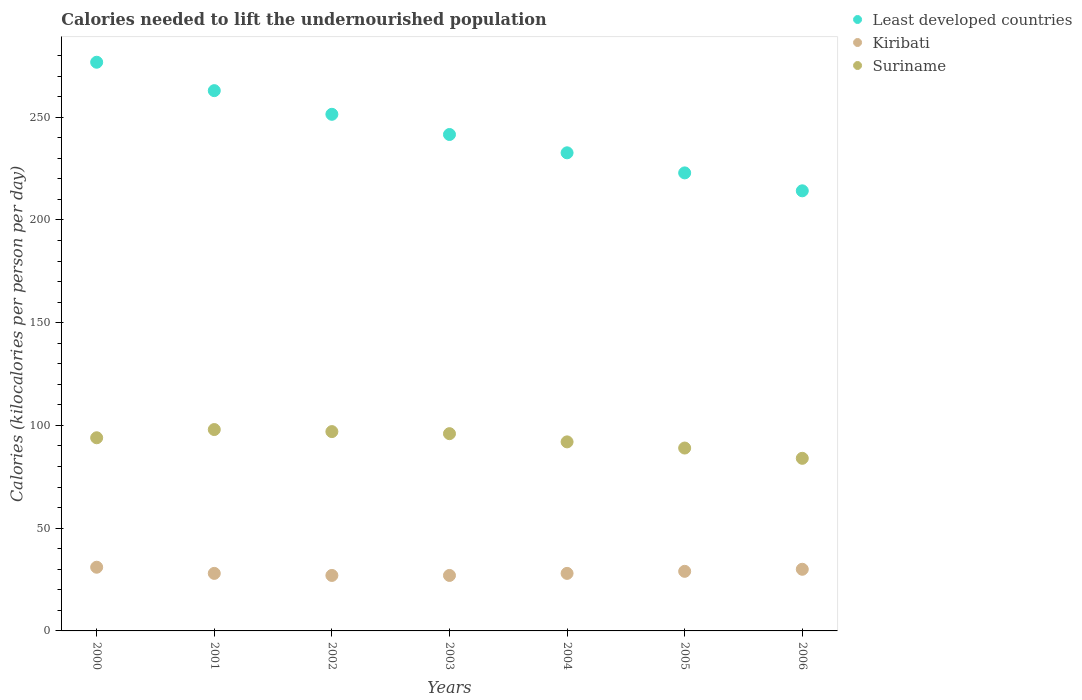Is the number of dotlines equal to the number of legend labels?
Provide a short and direct response. Yes. What is the total calories needed to lift the undernourished population in Kiribati in 2002?
Provide a succinct answer. 27. Across all years, what is the maximum total calories needed to lift the undernourished population in Kiribati?
Make the answer very short. 31. Across all years, what is the minimum total calories needed to lift the undernourished population in Suriname?
Your answer should be very brief. 84. In which year was the total calories needed to lift the undernourished population in Suriname maximum?
Provide a succinct answer. 2001. What is the total total calories needed to lift the undernourished population in Kiribati in the graph?
Your response must be concise. 200. What is the difference between the total calories needed to lift the undernourished population in Suriname in 2004 and that in 2005?
Provide a short and direct response. 3. What is the difference between the total calories needed to lift the undernourished population in Least developed countries in 2001 and the total calories needed to lift the undernourished population in Suriname in 2000?
Give a very brief answer. 168.93. What is the average total calories needed to lift the undernourished population in Kiribati per year?
Offer a terse response. 28.57. In the year 2005, what is the difference between the total calories needed to lift the undernourished population in Suriname and total calories needed to lift the undernourished population in Least developed countries?
Keep it short and to the point. -133.9. What is the ratio of the total calories needed to lift the undernourished population in Least developed countries in 2005 to that in 2006?
Provide a short and direct response. 1.04. Is the total calories needed to lift the undernourished population in Suriname in 2000 less than that in 2005?
Provide a succinct answer. No. What is the difference between the highest and the lowest total calories needed to lift the undernourished population in Kiribati?
Your answer should be compact. 4. Is the sum of the total calories needed to lift the undernourished population in Kiribati in 2000 and 2001 greater than the maximum total calories needed to lift the undernourished population in Least developed countries across all years?
Your response must be concise. No. Is the total calories needed to lift the undernourished population in Kiribati strictly greater than the total calories needed to lift the undernourished population in Suriname over the years?
Provide a short and direct response. No. Is the total calories needed to lift the undernourished population in Suriname strictly less than the total calories needed to lift the undernourished population in Least developed countries over the years?
Ensure brevity in your answer.  Yes. How many dotlines are there?
Your response must be concise. 3. How are the legend labels stacked?
Keep it short and to the point. Vertical. What is the title of the graph?
Your answer should be compact. Calories needed to lift the undernourished population. Does "New Zealand" appear as one of the legend labels in the graph?
Provide a short and direct response. No. What is the label or title of the Y-axis?
Give a very brief answer. Calories (kilocalories per person per day). What is the Calories (kilocalories per person per day) of Least developed countries in 2000?
Keep it short and to the point. 276.76. What is the Calories (kilocalories per person per day) of Kiribati in 2000?
Your answer should be compact. 31. What is the Calories (kilocalories per person per day) in Suriname in 2000?
Your response must be concise. 94. What is the Calories (kilocalories per person per day) in Least developed countries in 2001?
Offer a very short reply. 262.93. What is the Calories (kilocalories per person per day) of Kiribati in 2001?
Make the answer very short. 28. What is the Calories (kilocalories per person per day) in Least developed countries in 2002?
Your answer should be very brief. 251.42. What is the Calories (kilocalories per person per day) of Kiribati in 2002?
Offer a very short reply. 27. What is the Calories (kilocalories per person per day) in Suriname in 2002?
Offer a very short reply. 97. What is the Calories (kilocalories per person per day) in Least developed countries in 2003?
Keep it short and to the point. 241.59. What is the Calories (kilocalories per person per day) of Kiribati in 2003?
Provide a short and direct response. 27. What is the Calories (kilocalories per person per day) in Suriname in 2003?
Provide a succinct answer. 96. What is the Calories (kilocalories per person per day) of Least developed countries in 2004?
Ensure brevity in your answer.  232.67. What is the Calories (kilocalories per person per day) in Kiribati in 2004?
Provide a short and direct response. 28. What is the Calories (kilocalories per person per day) of Suriname in 2004?
Offer a very short reply. 92. What is the Calories (kilocalories per person per day) in Least developed countries in 2005?
Provide a succinct answer. 222.9. What is the Calories (kilocalories per person per day) in Suriname in 2005?
Your answer should be very brief. 89. What is the Calories (kilocalories per person per day) in Least developed countries in 2006?
Your response must be concise. 214.18. What is the Calories (kilocalories per person per day) in Kiribati in 2006?
Provide a succinct answer. 30. Across all years, what is the maximum Calories (kilocalories per person per day) in Least developed countries?
Provide a short and direct response. 276.76. Across all years, what is the maximum Calories (kilocalories per person per day) in Kiribati?
Give a very brief answer. 31. Across all years, what is the maximum Calories (kilocalories per person per day) in Suriname?
Provide a succinct answer. 98. Across all years, what is the minimum Calories (kilocalories per person per day) in Least developed countries?
Your response must be concise. 214.18. Across all years, what is the minimum Calories (kilocalories per person per day) in Kiribati?
Your answer should be very brief. 27. What is the total Calories (kilocalories per person per day) in Least developed countries in the graph?
Make the answer very short. 1702.46. What is the total Calories (kilocalories per person per day) in Kiribati in the graph?
Your answer should be compact. 200. What is the total Calories (kilocalories per person per day) of Suriname in the graph?
Make the answer very short. 650. What is the difference between the Calories (kilocalories per person per day) in Least developed countries in 2000 and that in 2001?
Keep it short and to the point. 13.82. What is the difference between the Calories (kilocalories per person per day) of Kiribati in 2000 and that in 2001?
Provide a short and direct response. 3. What is the difference between the Calories (kilocalories per person per day) of Suriname in 2000 and that in 2001?
Provide a short and direct response. -4. What is the difference between the Calories (kilocalories per person per day) in Least developed countries in 2000 and that in 2002?
Your response must be concise. 25.34. What is the difference between the Calories (kilocalories per person per day) of Kiribati in 2000 and that in 2002?
Your answer should be very brief. 4. What is the difference between the Calories (kilocalories per person per day) in Suriname in 2000 and that in 2002?
Give a very brief answer. -3. What is the difference between the Calories (kilocalories per person per day) of Least developed countries in 2000 and that in 2003?
Ensure brevity in your answer.  35.17. What is the difference between the Calories (kilocalories per person per day) of Suriname in 2000 and that in 2003?
Your response must be concise. -2. What is the difference between the Calories (kilocalories per person per day) of Least developed countries in 2000 and that in 2004?
Give a very brief answer. 44.08. What is the difference between the Calories (kilocalories per person per day) in Suriname in 2000 and that in 2004?
Provide a short and direct response. 2. What is the difference between the Calories (kilocalories per person per day) in Least developed countries in 2000 and that in 2005?
Offer a terse response. 53.85. What is the difference between the Calories (kilocalories per person per day) of Least developed countries in 2000 and that in 2006?
Offer a very short reply. 62.58. What is the difference between the Calories (kilocalories per person per day) of Least developed countries in 2001 and that in 2002?
Your answer should be very brief. 11.51. What is the difference between the Calories (kilocalories per person per day) in Kiribati in 2001 and that in 2002?
Your answer should be very brief. 1. What is the difference between the Calories (kilocalories per person per day) of Suriname in 2001 and that in 2002?
Your answer should be very brief. 1. What is the difference between the Calories (kilocalories per person per day) of Least developed countries in 2001 and that in 2003?
Provide a short and direct response. 21.34. What is the difference between the Calories (kilocalories per person per day) in Least developed countries in 2001 and that in 2004?
Keep it short and to the point. 30.26. What is the difference between the Calories (kilocalories per person per day) of Kiribati in 2001 and that in 2004?
Make the answer very short. 0. What is the difference between the Calories (kilocalories per person per day) of Least developed countries in 2001 and that in 2005?
Your answer should be very brief. 40.03. What is the difference between the Calories (kilocalories per person per day) in Least developed countries in 2001 and that in 2006?
Provide a succinct answer. 48.75. What is the difference between the Calories (kilocalories per person per day) in Least developed countries in 2002 and that in 2003?
Offer a very short reply. 9.83. What is the difference between the Calories (kilocalories per person per day) of Suriname in 2002 and that in 2003?
Give a very brief answer. 1. What is the difference between the Calories (kilocalories per person per day) in Least developed countries in 2002 and that in 2004?
Make the answer very short. 18.74. What is the difference between the Calories (kilocalories per person per day) of Kiribati in 2002 and that in 2004?
Your answer should be very brief. -1. What is the difference between the Calories (kilocalories per person per day) of Least developed countries in 2002 and that in 2005?
Offer a terse response. 28.51. What is the difference between the Calories (kilocalories per person per day) of Suriname in 2002 and that in 2005?
Provide a succinct answer. 8. What is the difference between the Calories (kilocalories per person per day) in Least developed countries in 2002 and that in 2006?
Offer a very short reply. 37.24. What is the difference between the Calories (kilocalories per person per day) in Least developed countries in 2003 and that in 2004?
Offer a terse response. 8.92. What is the difference between the Calories (kilocalories per person per day) in Least developed countries in 2003 and that in 2005?
Your answer should be compact. 18.69. What is the difference between the Calories (kilocalories per person per day) in Least developed countries in 2003 and that in 2006?
Provide a succinct answer. 27.41. What is the difference between the Calories (kilocalories per person per day) of Kiribati in 2003 and that in 2006?
Your answer should be compact. -3. What is the difference between the Calories (kilocalories per person per day) of Suriname in 2003 and that in 2006?
Make the answer very short. 12. What is the difference between the Calories (kilocalories per person per day) in Least developed countries in 2004 and that in 2005?
Your response must be concise. 9.77. What is the difference between the Calories (kilocalories per person per day) of Suriname in 2004 and that in 2005?
Offer a terse response. 3. What is the difference between the Calories (kilocalories per person per day) of Least developed countries in 2004 and that in 2006?
Offer a terse response. 18.49. What is the difference between the Calories (kilocalories per person per day) of Kiribati in 2004 and that in 2006?
Provide a succinct answer. -2. What is the difference between the Calories (kilocalories per person per day) of Suriname in 2004 and that in 2006?
Offer a very short reply. 8. What is the difference between the Calories (kilocalories per person per day) in Least developed countries in 2005 and that in 2006?
Offer a very short reply. 8.72. What is the difference between the Calories (kilocalories per person per day) of Least developed countries in 2000 and the Calories (kilocalories per person per day) of Kiribati in 2001?
Your answer should be very brief. 248.76. What is the difference between the Calories (kilocalories per person per day) of Least developed countries in 2000 and the Calories (kilocalories per person per day) of Suriname in 2001?
Provide a succinct answer. 178.76. What is the difference between the Calories (kilocalories per person per day) of Kiribati in 2000 and the Calories (kilocalories per person per day) of Suriname in 2001?
Give a very brief answer. -67. What is the difference between the Calories (kilocalories per person per day) in Least developed countries in 2000 and the Calories (kilocalories per person per day) in Kiribati in 2002?
Keep it short and to the point. 249.76. What is the difference between the Calories (kilocalories per person per day) in Least developed countries in 2000 and the Calories (kilocalories per person per day) in Suriname in 2002?
Your response must be concise. 179.76. What is the difference between the Calories (kilocalories per person per day) of Kiribati in 2000 and the Calories (kilocalories per person per day) of Suriname in 2002?
Ensure brevity in your answer.  -66. What is the difference between the Calories (kilocalories per person per day) in Least developed countries in 2000 and the Calories (kilocalories per person per day) in Kiribati in 2003?
Offer a very short reply. 249.76. What is the difference between the Calories (kilocalories per person per day) of Least developed countries in 2000 and the Calories (kilocalories per person per day) of Suriname in 2003?
Your answer should be very brief. 180.76. What is the difference between the Calories (kilocalories per person per day) in Kiribati in 2000 and the Calories (kilocalories per person per day) in Suriname in 2003?
Your answer should be compact. -65. What is the difference between the Calories (kilocalories per person per day) of Least developed countries in 2000 and the Calories (kilocalories per person per day) of Kiribati in 2004?
Ensure brevity in your answer.  248.76. What is the difference between the Calories (kilocalories per person per day) in Least developed countries in 2000 and the Calories (kilocalories per person per day) in Suriname in 2004?
Give a very brief answer. 184.76. What is the difference between the Calories (kilocalories per person per day) of Kiribati in 2000 and the Calories (kilocalories per person per day) of Suriname in 2004?
Ensure brevity in your answer.  -61. What is the difference between the Calories (kilocalories per person per day) in Least developed countries in 2000 and the Calories (kilocalories per person per day) in Kiribati in 2005?
Your answer should be compact. 247.76. What is the difference between the Calories (kilocalories per person per day) in Least developed countries in 2000 and the Calories (kilocalories per person per day) in Suriname in 2005?
Provide a succinct answer. 187.76. What is the difference between the Calories (kilocalories per person per day) of Kiribati in 2000 and the Calories (kilocalories per person per day) of Suriname in 2005?
Your answer should be compact. -58. What is the difference between the Calories (kilocalories per person per day) of Least developed countries in 2000 and the Calories (kilocalories per person per day) of Kiribati in 2006?
Give a very brief answer. 246.76. What is the difference between the Calories (kilocalories per person per day) of Least developed countries in 2000 and the Calories (kilocalories per person per day) of Suriname in 2006?
Ensure brevity in your answer.  192.76. What is the difference between the Calories (kilocalories per person per day) in Kiribati in 2000 and the Calories (kilocalories per person per day) in Suriname in 2006?
Provide a short and direct response. -53. What is the difference between the Calories (kilocalories per person per day) in Least developed countries in 2001 and the Calories (kilocalories per person per day) in Kiribati in 2002?
Offer a terse response. 235.93. What is the difference between the Calories (kilocalories per person per day) of Least developed countries in 2001 and the Calories (kilocalories per person per day) of Suriname in 2002?
Your answer should be very brief. 165.93. What is the difference between the Calories (kilocalories per person per day) in Kiribati in 2001 and the Calories (kilocalories per person per day) in Suriname in 2002?
Offer a terse response. -69. What is the difference between the Calories (kilocalories per person per day) in Least developed countries in 2001 and the Calories (kilocalories per person per day) in Kiribati in 2003?
Provide a short and direct response. 235.93. What is the difference between the Calories (kilocalories per person per day) in Least developed countries in 2001 and the Calories (kilocalories per person per day) in Suriname in 2003?
Make the answer very short. 166.93. What is the difference between the Calories (kilocalories per person per day) in Kiribati in 2001 and the Calories (kilocalories per person per day) in Suriname in 2003?
Give a very brief answer. -68. What is the difference between the Calories (kilocalories per person per day) in Least developed countries in 2001 and the Calories (kilocalories per person per day) in Kiribati in 2004?
Offer a terse response. 234.93. What is the difference between the Calories (kilocalories per person per day) in Least developed countries in 2001 and the Calories (kilocalories per person per day) in Suriname in 2004?
Provide a succinct answer. 170.93. What is the difference between the Calories (kilocalories per person per day) in Kiribati in 2001 and the Calories (kilocalories per person per day) in Suriname in 2004?
Ensure brevity in your answer.  -64. What is the difference between the Calories (kilocalories per person per day) in Least developed countries in 2001 and the Calories (kilocalories per person per day) in Kiribati in 2005?
Make the answer very short. 233.93. What is the difference between the Calories (kilocalories per person per day) in Least developed countries in 2001 and the Calories (kilocalories per person per day) in Suriname in 2005?
Keep it short and to the point. 173.93. What is the difference between the Calories (kilocalories per person per day) of Kiribati in 2001 and the Calories (kilocalories per person per day) of Suriname in 2005?
Provide a short and direct response. -61. What is the difference between the Calories (kilocalories per person per day) of Least developed countries in 2001 and the Calories (kilocalories per person per day) of Kiribati in 2006?
Provide a short and direct response. 232.93. What is the difference between the Calories (kilocalories per person per day) of Least developed countries in 2001 and the Calories (kilocalories per person per day) of Suriname in 2006?
Keep it short and to the point. 178.93. What is the difference between the Calories (kilocalories per person per day) in Kiribati in 2001 and the Calories (kilocalories per person per day) in Suriname in 2006?
Provide a short and direct response. -56. What is the difference between the Calories (kilocalories per person per day) in Least developed countries in 2002 and the Calories (kilocalories per person per day) in Kiribati in 2003?
Offer a terse response. 224.42. What is the difference between the Calories (kilocalories per person per day) in Least developed countries in 2002 and the Calories (kilocalories per person per day) in Suriname in 2003?
Offer a terse response. 155.42. What is the difference between the Calories (kilocalories per person per day) of Kiribati in 2002 and the Calories (kilocalories per person per day) of Suriname in 2003?
Provide a short and direct response. -69. What is the difference between the Calories (kilocalories per person per day) in Least developed countries in 2002 and the Calories (kilocalories per person per day) in Kiribati in 2004?
Your answer should be compact. 223.42. What is the difference between the Calories (kilocalories per person per day) in Least developed countries in 2002 and the Calories (kilocalories per person per day) in Suriname in 2004?
Your answer should be very brief. 159.42. What is the difference between the Calories (kilocalories per person per day) of Kiribati in 2002 and the Calories (kilocalories per person per day) of Suriname in 2004?
Your answer should be compact. -65. What is the difference between the Calories (kilocalories per person per day) of Least developed countries in 2002 and the Calories (kilocalories per person per day) of Kiribati in 2005?
Your answer should be very brief. 222.42. What is the difference between the Calories (kilocalories per person per day) of Least developed countries in 2002 and the Calories (kilocalories per person per day) of Suriname in 2005?
Give a very brief answer. 162.42. What is the difference between the Calories (kilocalories per person per day) in Kiribati in 2002 and the Calories (kilocalories per person per day) in Suriname in 2005?
Provide a succinct answer. -62. What is the difference between the Calories (kilocalories per person per day) of Least developed countries in 2002 and the Calories (kilocalories per person per day) of Kiribati in 2006?
Give a very brief answer. 221.42. What is the difference between the Calories (kilocalories per person per day) of Least developed countries in 2002 and the Calories (kilocalories per person per day) of Suriname in 2006?
Give a very brief answer. 167.42. What is the difference between the Calories (kilocalories per person per day) of Kiribati in 2002 and the Calories (kilocalories per person per day) of Suriname in 2006?
Make the answer very short. -57. What is the difference between the Calories (kilocalories per person per day) of Least developed countries in 2003 and the Calories (kilocalories per person per day) of Kiribati in 2004?
Keep it short and to the point. 213.59. What is the difference between the Calories (kilocalories per person per day) in Least developed countries in 2003 and the Calories (kilocalories per person per day) in Suriname in 2004?
Keep it short and to the point. 149.59. What is the difference between the Calories (kilocalories per person per day) in Kiribati in 2003 and the Calories (kilocalories per person per day) in Suriname in 2004?
Offer a very short reply. -65. What is the difference between the Calories (kilocalories per person per day) in Least developed countries in 2003 and the Calories (kilocalories per person per day) in Kiribati in 2005?
Ensure brevity in your answer.  212.59. What is the difference between the Calories (kilocalories per person per day) of Least developed countries in 2003 and the Calories (kilocalories per person per day) of Suriname in 2005?
Make the answer very short. 152.59. What is the difference between the Calories (kilocalories per person per day) in Kiribati in 2003 and the Calories (kilocalories per person per day) in Suriname in 2005?
Your response must be concise. -62. What is the difference between the Calories (kilocalories per person per day) of Least developed countries in 2003 and the Calories (kilocalories per person per day) of Kiribati in 2006?
Make the answer very short. 211.59. What is the difference between the Calories (kilocalories per person per day) of Least developed countries in 2003 and the Calories (kilocalories per person per day) of Suriname in 2006?
Offer a very short reply. 157.59. What is the difference between the Calories (kilocalories per person per day) of Kiribati in 2003 and the Calories (kilocalories per person per day) of Suriname in 2006?
Offer a terse response. -57. What is the difference between the Calories (kilocalories per person per day) in Least developed countries in 2004 and the Calories (kilocalories per person per day) in Kiribati in 2005?
Provide a succinct answer. 203.67. What is the difference between the Calories (kilocalories per person per day) in Least developed countries in 2004 and the Calories (kilocalories per person per day) in Suriname in 2005?
Offer a very short reply. 143.67. What is the difference between the Calories (kilocalories per person per day) in Kiribati in 2004 and the Calories (kilocalories per person per day) in Suriname in 2005?
Your response must be concise. -61. What is the difference between the Calories (kilocalories per person per day) in Least developed countries in 2004 and the Calories (kilocalories per person per day) in Kiribati in 2006?
Your response must be concise. 202.67. What is the difference between the Calories (kilocalories per person per day) of Least developed countries in 2004 and the Calories (kilocalories per person per day) of Suriname in 2006?
Your response must be concise. 148.67. What is the difference between the Calories (kilocalories per person per day) in Kiribati in 2004 and the Calories (kilocalories per person per day) in Suriname in 2006?
Give a very brief answer. -56. What is the difference between the Calories (kilocalories per person per day) of Least developed countries in 2005 and the Calories (kilocalories per person per day) of Kiribati in 2006?
Offer a terse response. 192.9. What is the difference between the Calories (kilocalories per person per day) of Least developed countries in 2005 and the Calories (kilocalories per person per day) of Suriname in 2006?
Provide a short and direct response. 138.9. What is the difference between the Calories (kilocalories per person per day) in Kiribati in 2005 and the Calories (kilocalories per person per day) in Suriname in 2006?
Your response must be concise. -55. What is the average Calories (kilocalories per person per day) in Least developed countries per year?
Offer a very short reply. 243.21. What is the average Calories (kilocalories per person per day) in Kiribati per year?
Your response must be concise. 28.57. What is the average Calories (kilocalories per person per day) in Suriname per year?
Provide a succinct answer. 92.86. In the year 2000, what is the difference between the Calories (kilocalories per person per day) in Least developed countries and Calories (kilocalories per person per day) in Kiribati?
Offer a terse response. 245.76. In the year 2000, what is the difference between the Calories (kilocalories per person per day) in Least developed countries and Calories (kilocalories per person per day) in Suriname?
Your response must be concise. 182.76. In the year 2000, what is the difference between the Calories (kilocalories per person per day) in Kiribati and Calories (kilocalories per person per day) in Suriname?
Your response must be concise. -63. In the year 2001, what is the difference between the Calories (kilocalories per person per day) in Least developed countries and Calories (kilocalories per person per day) in Kiribati?
Make the answer very short. 234.93. In the year 2001, what is the difference between the Calories (kilocalories per person per day) of Least developed countries and Calories (kilocalories per person per day) of Suriname?
Your answer should be very brief. 164.93. In the year 2001, what is the difference between the Calories (kilocalories per person per day) in Kiribati and Calories (kilocalories per person per day) in Suriname?
Keep it short and to the point. -70. In the year 2002, what is the difference between the Calories (kilocalories per person per day) in Least developed countries and Calories (kilocalories per person per day) in Kiribati?
Keep it short and to the point. 224.42. In the year 2002, what is the difference between the Calories (kilocalories per person per day) in Least developed countries and Calories (kilocalories per person per day) in Suriname?
Provide a succinct answer. 154.42. In the year 2002, what is the difference between the Calories (kilocalories per person per day) in Kiribati and Calories (kilocalories per person per day) in Suriname?
Provide a succinct answer. -70. In the year 2003, what is the difference between the Calories (kilocalories per person per day) in Least developed countries and Calories (kilocalories per person per day) in Kiribati?
Provide a succinct answer. 214.59. In the year 2003, what is the difference between the Calories (kilocalories per person per day) in Least developed countries and Calories (kilocalories per person per day) in Suriname?
Offer a very short reply. 145.59. In the year 2003, what is the difference between the Calories (kilocalories per person per day) of Kiribati and Calories (kilocalories per person per day) of Suriname?
Ensure brevity in your answer.  -69. In the year 2004, what is the difference between the Calories (kilocalories per person per day) of Least developed countries and Calories (kilocalories per person per day) of Kiribati?
Ensure brevity in your answer.  204.67. In the year 2004, what is the difference between the Calories (kilocalories per person per day) of Least developed countries and Calories (kilocalories per person per day) of Suriname?
Make the answer very short. 140.67. In the year 2004, what is the difference between the Calories (kilocalories per person per day) in Kiribati and Calories (kilocalories per person per day) in Suriname?
Make the answer very short. -64. In the year 2005, what is the difference between the Calories (kilocalories per person per day) of Least developed countries and Calories (kilocalories per person per day) of Kiribati?
Provide a short and direct response. 193.9. In the year 2005, what is the difference between the Calories (kilocalories per person per day) in Least developed countries and Calories (kilocalories per person per day) in Suriname?
Your answer should be very brief. 133.9. In the year 2005, what is the difference between the Calories (kilocalories per person per day) in Kiribati and Calories (kilocalories per person per day) in Suriname?
Give a very brief answer. -60. In the year 2006, what is the difference between the Calories (kilocalories per person per day) of Least developed countries and Calories (kilocalories per person per day) of Kiribati?
Your answer should be compact. 184.18. In the year 2006, what is the difference between the Calories (kilocalories per person per day) of Least developed countries and Calories (kilocalories per person per day) of Suriname?
Give a very brief answer. 130.18. In the year 2006, what is the difference between the Calories (kilocalories per person per day) in Kiribati and Calories (kilocalories per person per day) in Suriname?
Offer a very short reply. -54. What is the ratio of the Calories (kilocalories per person per day) in Least developed countries in 2000 to that in 2001?
Give a very brief answer. 1.05. What is the ratio of the Calories (kilocalories per person per day) of Kiribati in 2000 to that in 2001?
Ensure brevity in your answer.  1.11. What is the ratio of the Calories (kilocalories per person per day) in Suriname in 2000 to that in 2001?
Ensure brevity in your answer.  0.96. What is the ratio of the Calories (kilocalories per person per day) in Least developed countries in 2000 to that in 2002?
Make the answer very short. 1.1. What is the ratio of the Calories (kilocalories per person per day) in Kiribati in 2000 to that in 2002?
Offer a terse response. 1.15. What is the ratio of the Calories (kilocalories per person per day) in Suriname in 2000 to that in 2002?
Provide a short and direct response. 0.97. What is the ratio of the Calories (kilocalories per person per day) of Least developed countries in 2000 to that in 2003?
Keep it short and to the point. 1.15. What is the ratio of the Calories (kilocalories per person per day) in Kiribati in 2000 to that in 2003?
Provide a succinct answer. 1.15. What is the ratio of the Calories (kilocalories per person per day) of Suriname in 2000 to that in 2003?
Give a very brief answer. 0.98. What is the ratio of the Calories (kilocalories per person per day) of Least developed countries in 2000 to that in 2004?
Provide a short and direct response. 1.19. What is the ratio of the Calories (kilocalories per person per day) of Kiribati in 2000 to that in 2004?
Give a very brief answer. 1.11. What is the ratio of the Calories (kilocalories per person per day) in Suriname in 2000 to that in 2004?
Give a very brief answer. 1.02. What is the ratio of the Calories (kilocalories per person per day) in Least developed countries in 2000 to that in 2005?
Make the answer very short. 1.24. What is the ratio of the Calories (kilocalories per person per day) of Kiribati in 2000 to that in 2005?
Your answer should be very brief. 1.07. What is the ratio of the Calories (kilocalories per person per day) of Suriname in 2000 to that in 2005?
Give a very brief answer. 1.06. What is the ratio of the Calories (kilocalories per person per day) in Least developed countries in 2000 to that in 2006?
Your response must be concise. 1.29. What is the ratio of the Calories (kilocalories per person per day) in Kiribati in 2000 to that in 2006?
Make the answer very short. 1.03. What is the ratio of the Calories (kilocalories per person per day) in Suriname in 2000 to that in 2006?
Your answer should be compact. 1.12. What is the ratio of the Calories (kilocalories per person per day) of Least developed countries in 2001 to that in 2002?
Provide a succinct answer. 1.05. What is the ratio of the Calories (kilocalories per person per day) of Kiribati in 2001 to that in 2002?
Your answer should be compact. 1.04. What is the ratio of the Calories (kilocalories per person per day) of Suriname in 2001 to that in 2002?
Your answer should be compact. 1.01. What is the ratio of the Calories (kilocalories per person per day) of Least developed countries in 2001 to that in 2003?
Ensure brevity in your answer.  1.09. What is the ratio of the Calories (kilocalories per person per day) of Suriname in 2001 to that in 2003?
Offer a very short reply. 1.02. What is the ratio of the Calories (kilocalories per person per day) in Least developed countries in 2001 to that in 2004?
Give a very brief answer. 1.13. What is the ratio of the Calories (kilocalories per person per day) in Kiribati in 2001 to that in 2004?
Offer a very short reply. 1. What is the ratio of the Calories (kilocalories per person per day) in Suriname in 2001 to that in 2004?
Ensure brevity in your answer.  1.07. What is the ratio of the Calories (kilocalories per person per day) of Least developed countries in 2001 to that in 2005?
Provide a succinct answer. 1.18. What is the ratio of the Calories (kilocalories per person per day) of Kiribati in 2001 to that in 2005?
Offer a very short reply. 0.97. What is the ratio of the Calories (kilocalories per person per day) in Suriname in 2001 to that in 2005?
Offer a very short reply. 1.1. What is the ratio of the Calories (kilocalories per person per day) in Least developed countries in 2001 to that in 2006?
Offer a terse response. 1.23. What is the ratio of the Calories (kilocalories per person per day) of Suriname in 2001 to that in 2006?
Provide a succinct answer. 1.17. What is the ratio of the Calories (kilocalories per person per day) of Least developed countries in 2002 to that in 2003?
Your answer should be very brief. 1.04. What is the ratio of the Calories (kilocalories per person per day) of Suriname in 2002 to that in 2003?
Offer a very short reply. 1.01. What is the ratio of the Calories (kilocalories per person per day) in Least developed countries in 2002 to that in 2004?
Provide a short and direct response. 1.08. What is the ratio of the Calories (kilocalories per person per day) in Suriname in 2002 to that in 2004?
Your answer should be compact. 1.05. What is the ratio of the Calories (kilocalories per person per day) in Least developed countries in 2002 to that in 2005?
Offer a terse response. 1.13. What is the ratio of the Calories (kilocalories per person per day) of Suriname in 2002 to that in 2005?
Provide a succinct answer. 1.09. What is the ratio of the Calories (kilocalories per person per day) of Least developed countries in 2002 to that in 2006?
Provide a succinct answer. 1.17. What is the ratio of the Calories (kilocalories per person per day) in Kiribati in 2002 to that in 2006?
Your response must be concise. 0.9. What is the ratio of the Calories (kilocalories per person per day) of Suriname in 2002 to that in 2006?
Your response must be concise. 1.15. What is the ratio of the Calories (kilocalories per person per day) in Least developed countries in 2003 to that in 2004?
Offer a terse response. 1.04. What is the ratio of the Calories (kilocalories per person per day) in Kiribati in 2003 to that in 2004?
Make the answer very short. 0.96. What is the ratio of the Calories (kilocalories per person per day) in Suriname in 2003 to that in 2004?
Your answer should be compact. 1.04. What is the ratio of the Calories (kilocalories per person per day) in Least developed countries in 2003 to that in 2005?
Offer a terse response. 1.08. What is the ratio of the Calories (kilocalories per person per day) of Kiribati in 2003 to that in 2005?
Offer a very short reply. 0.93. What is the ratio of the Calories (kilocalories per person per day) in Suriname in 2003 to that in 2005?
Provide a succinct answer. 1.08. What is the ratio of the Calories (kilocalories per person per day) of Least developed countries in 2003 to that in 2006?
Your answer should be very brief. 1.13. What is the ratio of the Calories (kilocalories per person per day) in Kiribati in 2003 to that in 2006?
Your answer should be very brief. 0.9. What is the ratio of the Calories (kilocalories per person per day) of Suriname in 2003 to that in 2006?
Provide a succinct answer. 1.14. What is the ratio of the Calories (kilocalories per person per day) of Least developed countries in 2004 to that in 2005?
Offer a very short reply. 1.04. What is the ratio of the Calories (kilocalories per person per day) of Kiribati in 2004 to that in 2005?
Your answer should be compact. 0.97. What is the ratio of the Calories (kilocalories per person per day) in Suriname in 2004 to that in 2005?
Offer a terse response. 1.03. What is the ratio of the Calories (kilocalories per person per day) in Least developed countries in 2004 to that in 2006?
Keep it short and to the point. 1.09. What is the ratio of the Calories (kilocalories per person per day) of Kiribati in 2004 to that in 2006?
Provide a short and direct response. 0.93. What is the ratio of the Calories (kilocalories per person per day) in Suriname in 2004 to that in 2006?
Make the answer very short. 1.1. What is the ratio of the Calories (kilocalories per person per day) in Least developed countries in 2005 to that in 2006?
Give a very brief answer. 1.04. What is the ratio of the Calories (kilocalories per person per day) in Kiribati in 2005 to that in 2006?
Your answer should be compact. 0.97. What is the ratio of the Calories (kilocalories per person per day) in Suriname in 2005 to that in 2006?
Your response must be concise. 1.06. What is the difference between the highest and the second highest Calories (kilocalories per person per day) of Least developed countries?
Provide a short and direct response. 13.82. What is the difference between the highest and the second highest Calories (kilocalories per person per day) in Kiribati?
Offer a terse response. 1. What is the difference between the highest and the second highest Calories (kilocalories per person per day) of Suriname?
Give a very brief answer. 1. What is the difference between the highest and the lowest Calories (kilocalories per person per day) of Least developed countries?
Give a very brief answer. 62.58. What is the difference between the highest and the lowest Calories (kilocalories per person per day) of Suriname?
Ensure brevity in your answer.  14. 